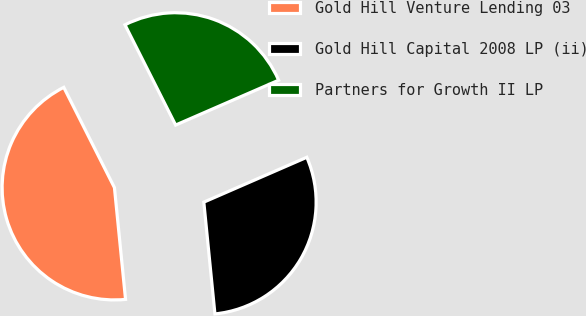Convert chart. <chart><loc_0><loc_0><loc_500><loc_500><pie_chart><fcel>Gold Hill Venture Lending 03<fcel>Gold Hill Capital 2008 LP (ii)<fcel>Partners for Growth II LP<nl><fcel>44.13%<fcel>29.96%<fcel>25.91%<nl></chart> 